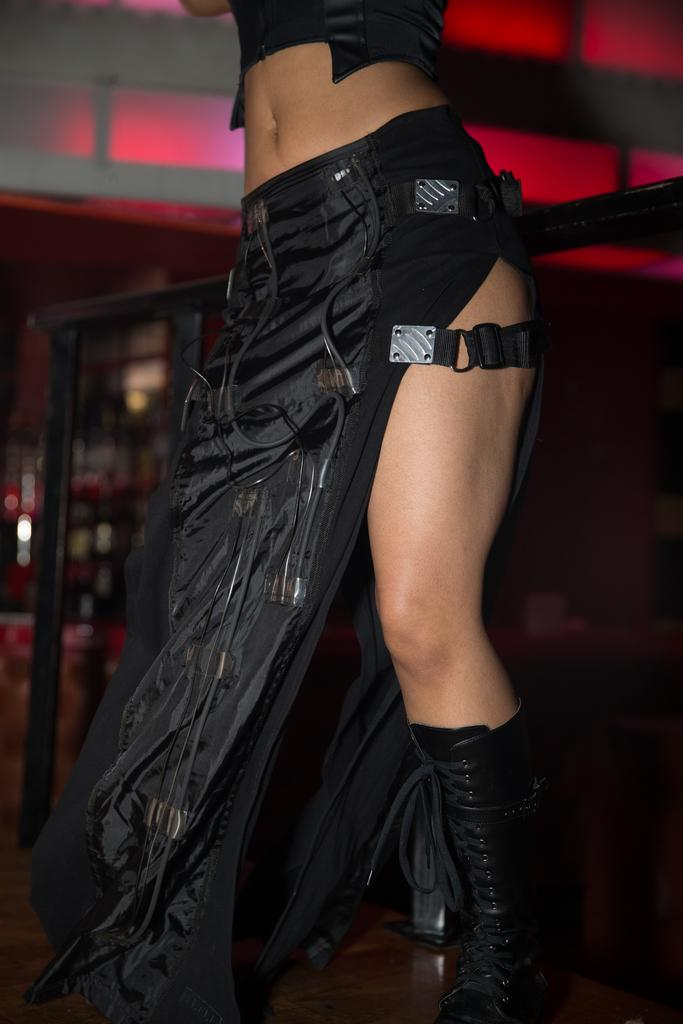Who or what is present in the image? There is a person in the image. What can be seen in the background of the image? There is a wall in the background of the image. What type of argument is the person having with the wall in the image? There is no argument present in the image; it only shows a person and a wall in the background. 